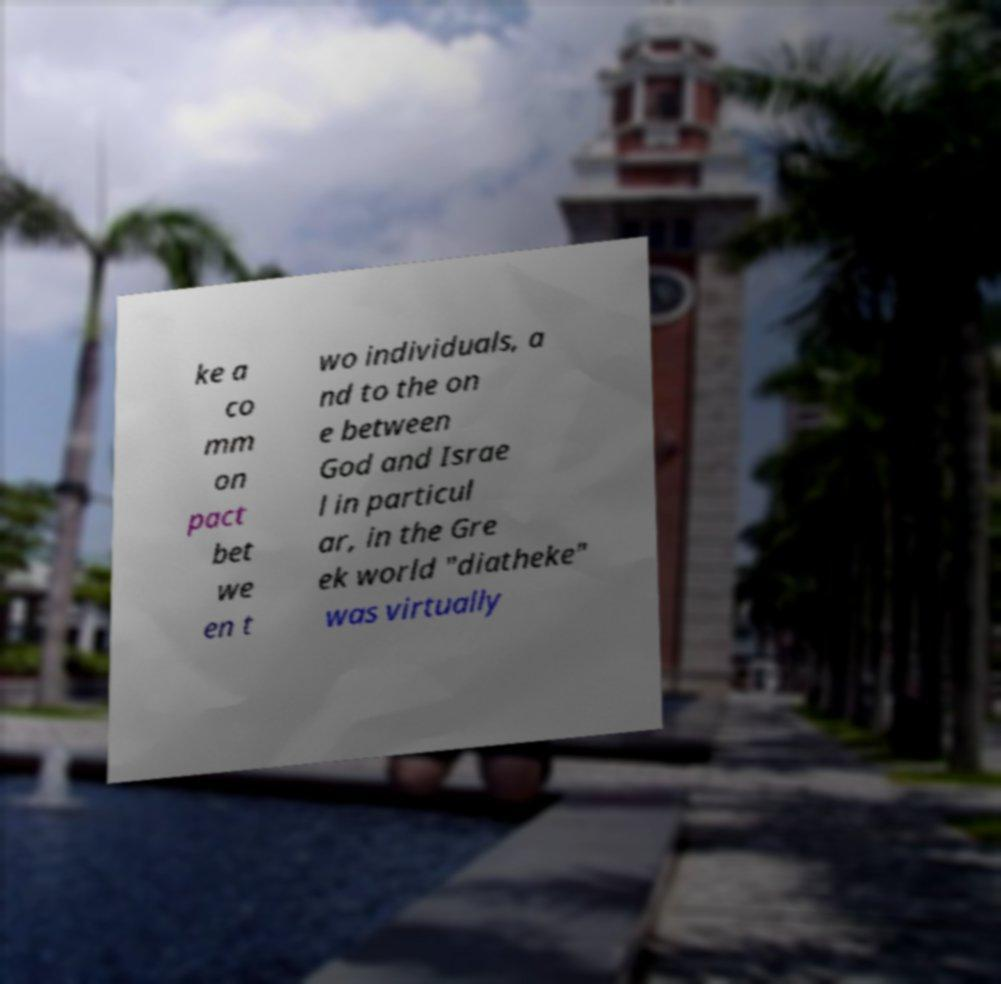For documentation purposes, I need the text within this image transcribed. Could you provide that? ke a co mm on pact bet we en t wo individuals, a nd to the on e between God and Israe l in particul ar, in the Gre ek world "diatheke" was virtually 